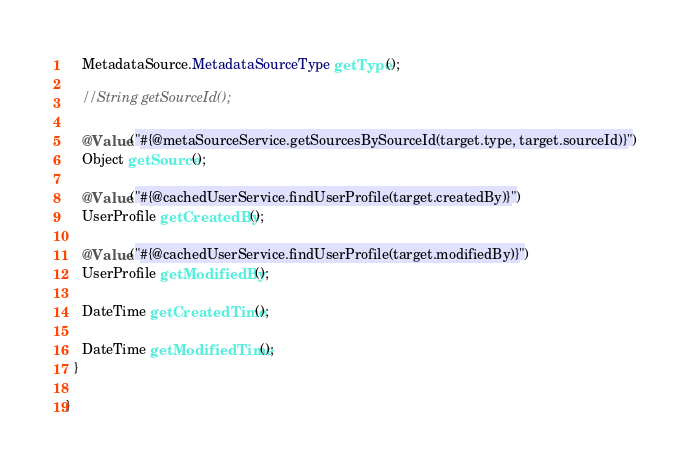Convert code to text. <code><loc_0><loc_0><loc_500><loc_500><_Java_>    MetadataSource.MetadataSourceType getType();

    //String getSourceId();

    @Value("#{@metaSourceService.getSourcesBySourceId(target.type, target.sourceId)}")
    Object getSource();

    @Value("#{@cachedUserService.findUserProfile(target.createdBy)}")
    UserProfile getCreatedBy();

    @Value("#{@cachedUserService.findUserProfile(target.modifiedBy)}")
    UserProfile getModifiedBy();

    DateTime getCreatedTime();

    DateTime getModifiedTime();
  }

}
</code> 